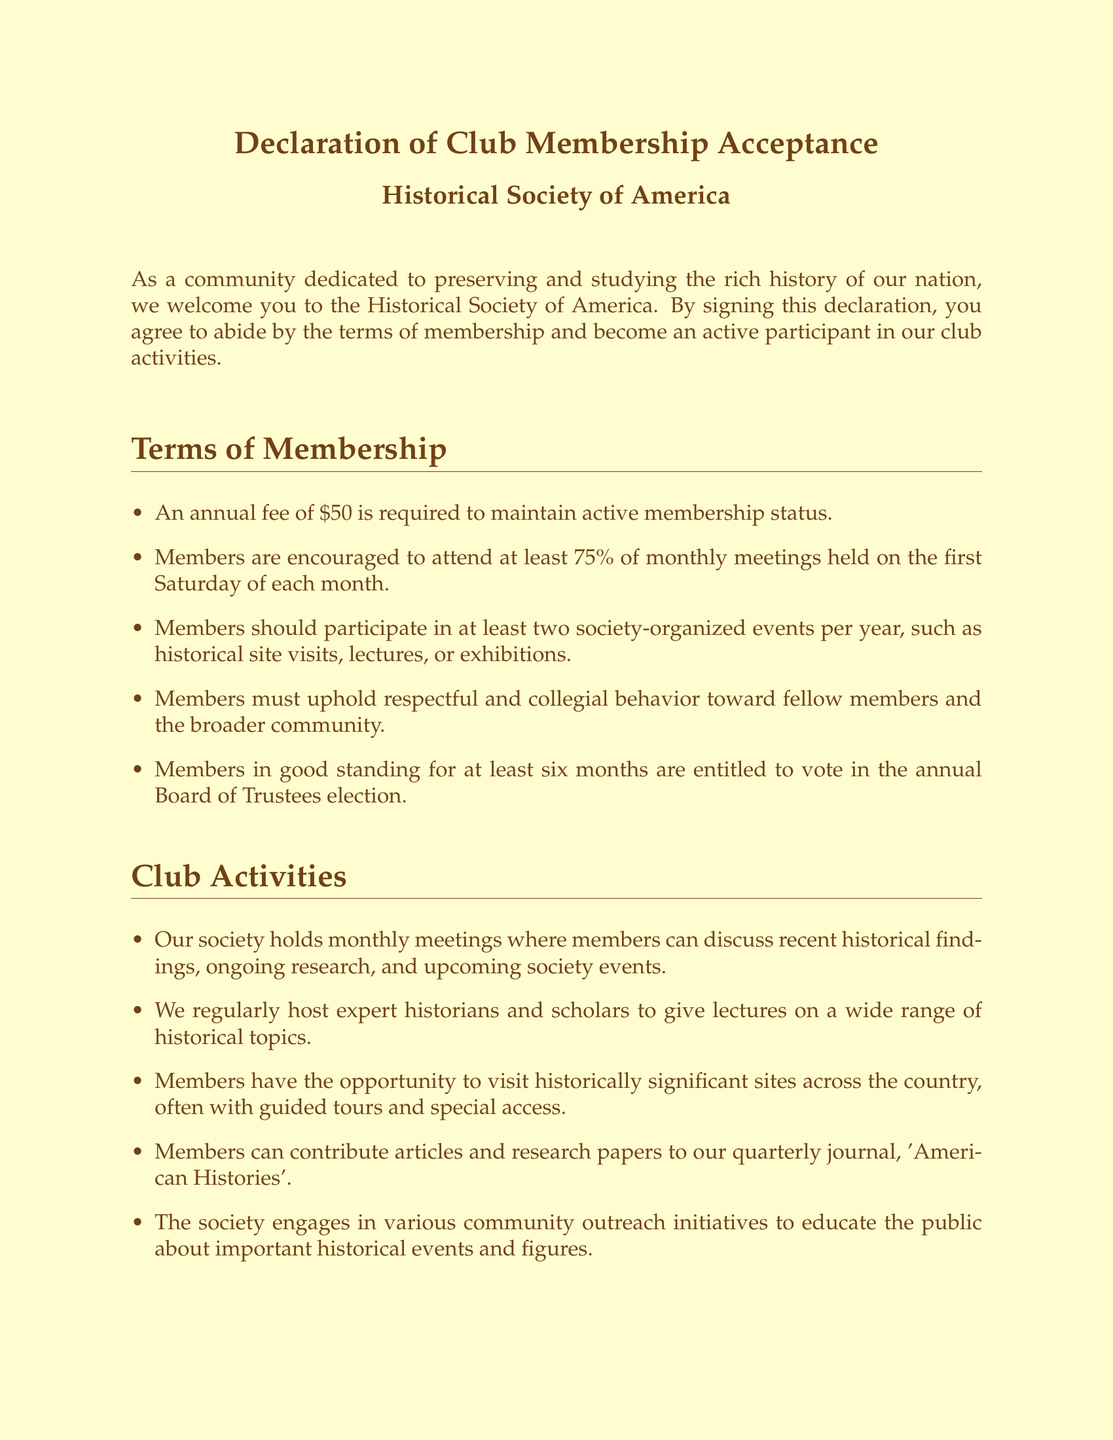What is the annual fee for membership? The annual fee for membership is stated in the terms of membership section.
Answer: $50 How often are the monthly meetings held? The frequency of the monthly meetings is mentioned in the terms of membership section.
Answer: First Saturday of each month How many society-organized events must members participate in per year? The document specifies the required participation in society events in the terms of membership section.
Answer: Two What is the title of the quarterly journal? The title of the journal is mentioned in the club activities section.
Answer: American Histories What type of behavior must members uphold? The requirements for member behavior are outlined in the terms of membership section.
Answer: Respectful and collegial behavior Who can vote in the annual Board of Trustees election? Eligibility to vote in the election is defined in the terms of membership section.
Answer: Members in good standing for at least six months What type of outreach does the society engage in? The type of activities related to community outreach is described in the club activities section.
Answer: Community outreach initiatives How can members contribute to the society? The document describes how members can contribute in the club activities section.
Answer: Articles and research papers What purpose does the Historical Society of America serve? The purpose of the society is stated in the introduction to the document.
Answer: Preserving and studying history 